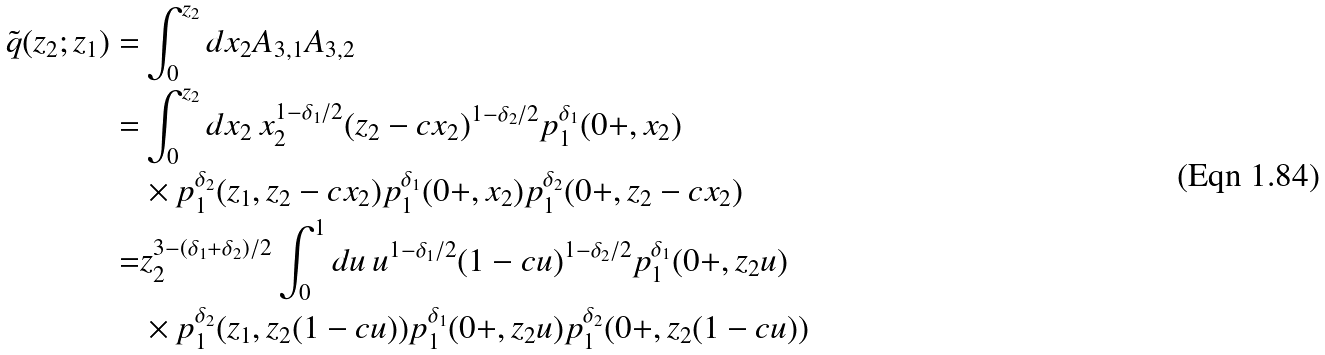<formula> <loc_0><loc_0><loc_500><loc_500>\tilde { q } ( z _ { 2 } ; z _ { 1 } ) = & \int _ { 0 } ^ { z _ { 2 } } d x _ { 2 } A _ { 3 , 1 } A _ { 3 , 2 } \\ = & \int _ { 0 } ^ { z _ { 2 } } d x _ { 2 } \, x _ { 2 } ^ { 1 - \delta _ { 1 } / 2 } ( z _ { 2 } - c x _ { 2 } ) ^ { 1 - \delta _ { 2 } / 2 } p _ { 1 } ^ { \delta _ { 1 } } ( 0 + , x _ { 2 } ) \\ & \times p _ { 1 } ^ { \delta _ { 2 } } ( z _ { 1 } , z _ { 2 } - c x _ { 2 } ) p _ { 1 } ^ { \delta _ { 1 } } ( 0 + , x _ { 2 } ) p _ { 1 } ^ { \delta _ { 2 } } ( 0 + , z _ { 2 } - c x _ { 2 } ) \\ = & z _ { 2 } ^ { 3 - ( \delta _ { 1 } + \delta _ { 2 } ) / 2 } \int _ { 0 } ^ { 1 } d u \, u ^ { 1 - \delta _ { 1 } / 2 } ( 1 - c u ) ^ { 1 - \delta _ { 2 } / 2 } p _ { 1 } ^ { \delta _ { 1 } } ( 0 + , z _ { 2 } u ) \\ & \times p _ { 1 } ^ { \delta _ { 2 } } ( z _ { 1 } , z _ { 2 } ( 1 - c u ) ) p _ { 1 } ^ { \delta _ { 1 } } ( 0 + , z _ { 2 } u ) p _ { 1 } ^ { \delta _ { 2 } } ( 0 + , z _ { 2 } ( 1 - c u ) )</formula> 